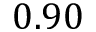<formula> <loc_0><loc_0><loc_500><loc_500>0 . 9 0</formula> 